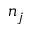<formula> <loc_0><loc_0><loc_500><loc_500>n _ { j }</formula> 